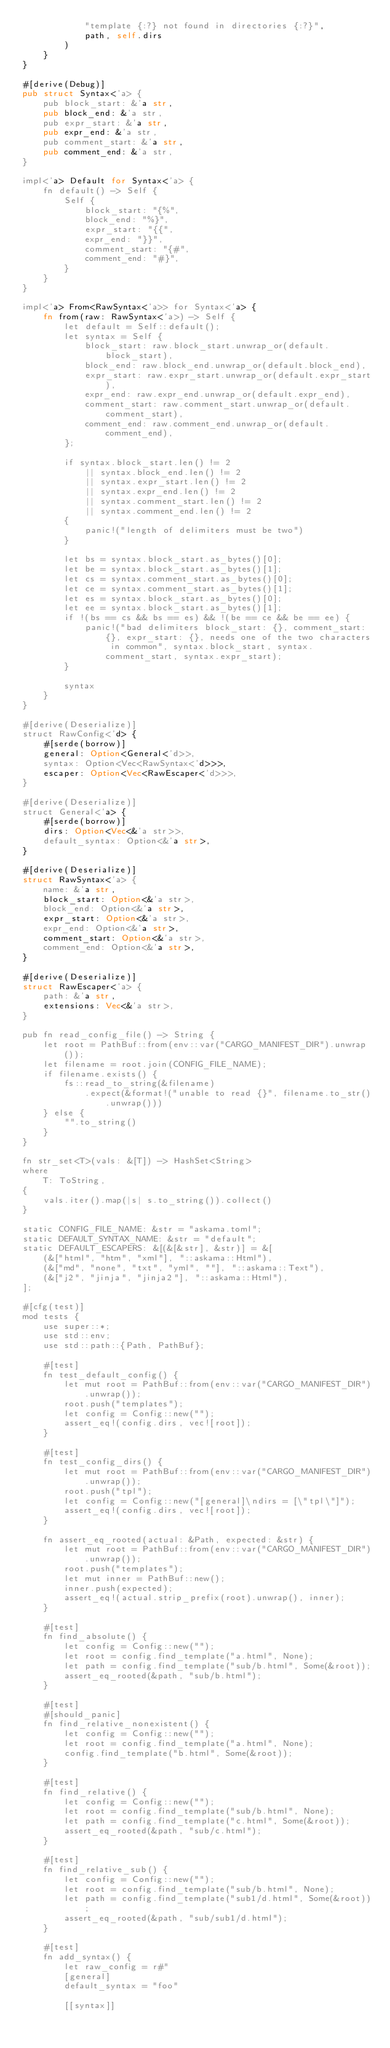<code> <loc_0><loc_0><loc_500><loc_500><_Rust_>            "template {:?} not found in directories {:?}",
            path, self.dirs
        )
    }
}

#[derive(Debug)]
pub struct Syntax<'a> {
    pub block_start: &'a str,
    pub block_end: &'a str,
    pub expr_start: &'a str,
    pub expr_end: &'a str,
    pub comment_start: &'a str,
    pub comment_end: &'a str,
}

impl<'a> Default for Syntax<'a> {
    fn default() -> Self {
        Self {
            block_start: "{%",
            block_end: "%}",
            expr_start: "{{",
            expr_end: "}}",
            comment_start: "{#",
            comment_end: "#}",
        }
    }
}

impl<'a> From<RawSyntax<'a>> for Syntax<'a> {
    fn from(raw: RawSyntax<'a>) -> Self {
        let default = Self::default();
        let syntax = Self {
            block_start: raw.block_start.unwrap_or(default.block_start),
            block_end: raw.block_end.unwrap_or(default.block_end),
            expr_start: raw.expr_start.unwrap_or(default.expr_start),
            expr_end: raw.expr_end.unwrap_or(default.expr_end),
            comment_start: raw.comment_start.unwrap_or(default.comment_start),
            comment_end: raw.comment_end.unwrap_or(default.comment_end),
        };

        if syntax.block_start.len() != 2
            || syntax.block_end.len() != 2
            || syntax.expr_start.len() != 2
            || syntax.expr_end.len() != 2
            || syntax.comment_start.len() != 2
            || syntax.comment_end.len() != 2
        {
            panic!("length of delimiters must be two")
        }

        let bs = syntax.block_start.as_bytes()[0];
        let be = syntax.block_start.as_bytes()[1];
        let cs = syntax.comment_start.as_bytes()[0];
        let ce = syntax.comment_start.as_bytes()[1];
        let es = syntax.block_start.as_bytes()[0];
        let ee = syntax.block_start.as_bytes()[1];
        if !(bs == cs && bs == es) && !(be == ce && be == ee) {
            panic!("bad delimiters block_start: {}, comment_start: {}, expr_start: {}, needs one of the two characters in common", syntax.block_start, syntax.comment_start, syntax.expr_start);
        }

        syntax
    }
}

#[derive(Deserialize)]
struct RawConfig<'d> {
    #[serde(borrow)]
    general: Option<General<'d>>,
    syntax: Option<Vec<RawSyntax<'d>>>,
    escaper: Option<Vec<RawEscaper<'d>>>,
}

#[derive(Deserialize)]
struct General<'a> {
    #[serde(borrow)]
    dirs: Option<Vec<&'a str>>,
    default_syntax: Option<&'a str>,
}

#[derive(Deserialize)]
struct RawSyntax<'a> {
    name: &'a str,
    block_start: Option<&'a str>,
    block_end: Option<&'a str>,
    expr_start: Option<&'a str>,
    expr_end: Option<&'a str>,
    comment_start: Option<&'a str>,
    comment_end: Option<&'a str>,
}

#[derive(Deserialize)]
struct RawEscaper<'a> {
    path: &'a str,
    extensions: Vec<&'a str>,
}

pub fn read_config_file() -> String {
    let root = PathBuf::from(env::var("CARGO_MANIFEST_DIR").unwrap());
    let filename = root.join(CONFIG_FILE_NAME);
    if filename.exists() {
        fs::read_to_string(&filename)
            .expect(&format!("unable to read {}", filename.to_str().unwrap()))
    } else {
        "".to_string()
    }
}

fn str_set<T>(vals: &[T]) -> HashSet<String>
where
    T: ToString,
{
    vals.iter().map(|s| s.to_string()).collect()
}

static CONFIG_FILE_NAME: &str = "askama.toml";
static DEFAULT_SYNTAX_NAME: &str = "default";
static DEFAULT_ESCAPERS: &[(&[&str], &str)] = &[
    (&["html", "htm", "xml"], "::askama::Html"),
    (&["md", "none", "txt", "yml", ""], "::askama::Text"),
    (&["j2", "jinja", "jinja2"], "::askama::Html"),
];

#[cfg(test)]
mod tests {
    use super::*;
    use std::env;
    use std::path::{Path, PathBuf};

    #[test]
    fn test_default_config() {
        let mut root = PathBuf::from(env::var("CARGO_MANIFEST_DIR").unwrap());
        root.push("templates");
        let config = Config::new("");
        assert_eq!(config.dirs, vec![root]);
    }

    #[test]
    fn test_config_dirs() {
        let mut root = PathBuf::from(env::var("CARGO_MANIFEST_DIR").unwrap());
        root.push("tpl");
        let config = Config::new("[general]\ndirs = [\"tpl\"]");
        assert_eq!(config.dirs, vec![root]);
    }

    fn assert_eq_rooted(actual: &Path, expected: &str) {
        let mut root = PathBuf::from(env::var("CARGO_MANIFEST_DIR").unwrap());
        root.push("templates");
        let mut inner = PathBuf::new();
        inner.push(expected);
        assert_eq!(actual.strip_prefix(root).unwrap(), inner);
    }

    #[test]
    fn find_absolute() {
        let config = Config::new("");
        let root = config.find_template("a.html", None);
        let path = config.find_template("sub/b.html", Some(&root));
        assert_eq_rooted(&path, "sub/b.html");
    }

    #[test]
    #[should_panic]
    fn find_relative_nonexistent() {
        let config = Config::new("");
        let root = config.find_template("a.html", None);
        config.find_template("b.html", Some(&root));
    }

    #[test]
    fn find_relative() {
        let config = Config::new("");
        let root = config.find_template("sub/b.html", None);
        let path = config.find_template("c.html", Some(&root));
        assert_eq_rooted(&path, "sub/c.html");
    }

    #[test]
    fn find_relative_sub() {
        let config = Config::new("");
        let root = config.find_template("sub/b.html", None);
        let path = config.find_template("sub1/d.html", Some(&root));
        assert_eq_rooted(&path, "sub/sub1/d.html");
    }

    #[test]
    fn add_syntax() {
        let raw_config = r#"
        [general]
        default_syntax = "foo"

        [[syntax]]</code> 